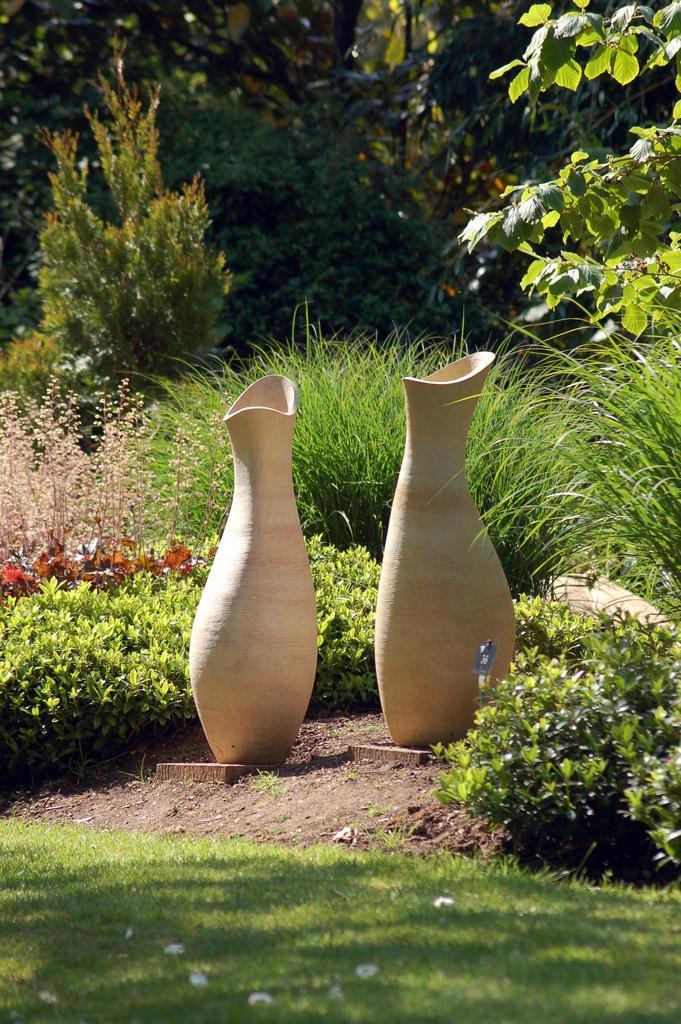Describe this image in one or two sentences. In this picture we can see the grass, plants, pots on the ground and in the background we can see trees. 